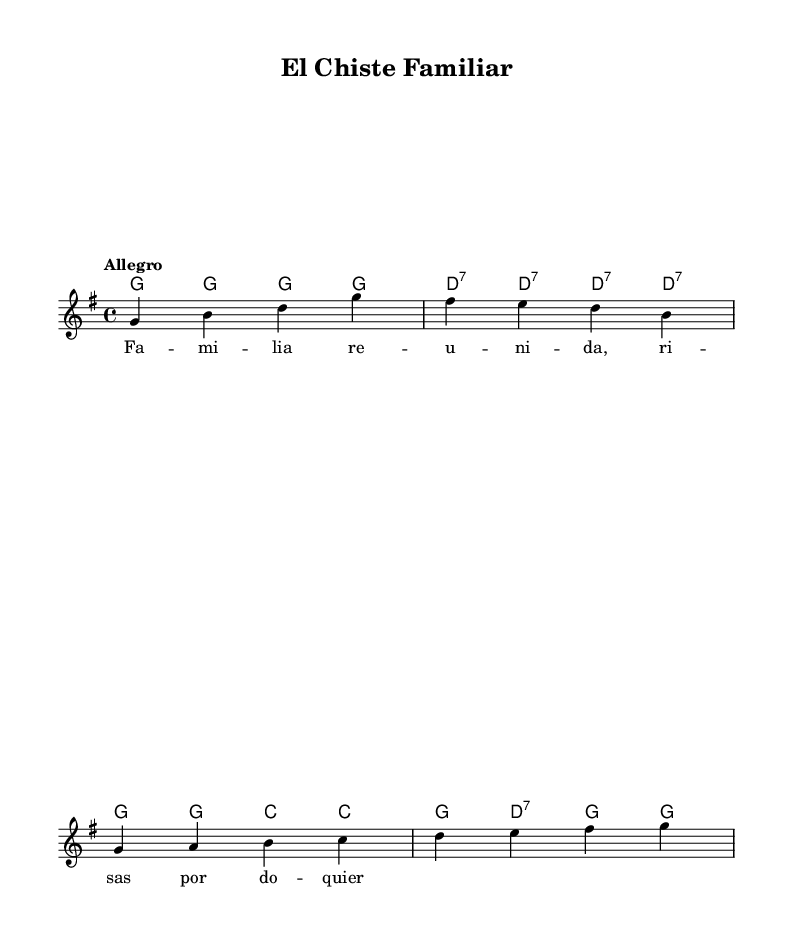What is the key signature of this music? The key signature shows the presence of one sharp (F#), which indicates the key of G major.
Answer: G major What is the time signature of this sheet music? The time signature is indicated at the beginning of the score as 4/4, meaning there are four beats in each measure.
Answer: 4/4 What is the tempo marking for this piece? The tempo marking at the beginning is "Allegro," which typically indicates a fast and lively pace for the music.
Answer: Allegro How many measures are in the melody? The melody consists of four full measures, as indicated by the vertical lines separating them in the notation.
Answer: Four What is the final chord of the chord progression? The last chord indicated in the harmonies is "g," which suggests it resolves back to the tonic G major chord.
Answer: g What lyrical theme is presented in the song? The lyrics depict a family gathering with laughter, as indicated by the thematic title "Fa - mi - lia re - u - ni - da, ri - sas por do - quier."
Answer: Family reunion What type of musical form does this piece represent? The song is likely structured around a simple verse-chorus format, common in festive mariachi music, where the melody and chords typically repeat after each verse.
Answer: Verse-chorus 